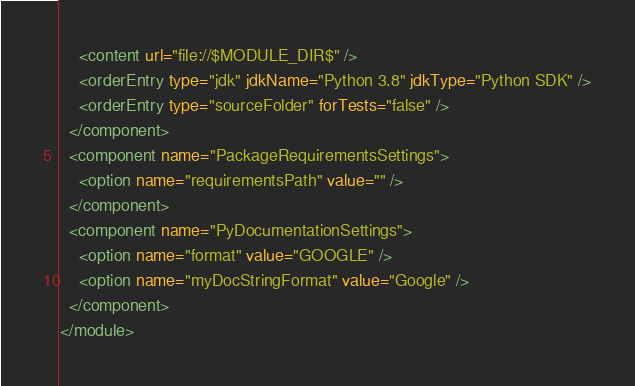Convert code to text. <code><loc_0><loc_0><loc_500><loc_500><_XML_>    <content url="file://$MODULE_DIR$" />
    <orderEntry type="jdk" jdkName="Python 3.8" jdkType="Python SDK" />
    <orderEntry type="sourceFolder" forTests="false" />
  </component>
  <component name="PackageRequirementsSettings">
    <option name="requirementsPath" value="" />
  </component>
  <component name="PyDocumentationSettings">
    <option name="format" value="GOOGLE" />
    <option name="myDocStringFormat" value="Google" />
  </component>
</module></code> 